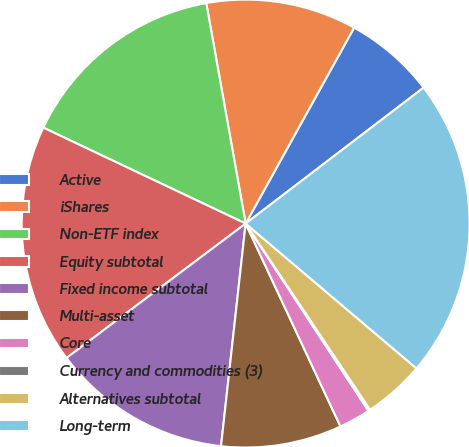Convert chart. <chart><loc_0><loc_0><loc_500><loc_500><pie_chart><fcel>Active<fcel>iShares<fcel>Non-ETF index<fcel>Equity subtotal<fcel>Fixed income subtotal<fcel>Multi-asset<fcel>Core<fcel>Currency and commodities (3)<fcel>Alternatives subtotal<fcel>Long-term<nl><fcel>6.57%<fcel>10.86%<fcel>15.14%<fcel>17.29%<fcel>13.0%<fcel>8.71%<fcel>2.28%<fcel>0.14%<fcel>4.43%<fcel>21.57%<nl></chart> 